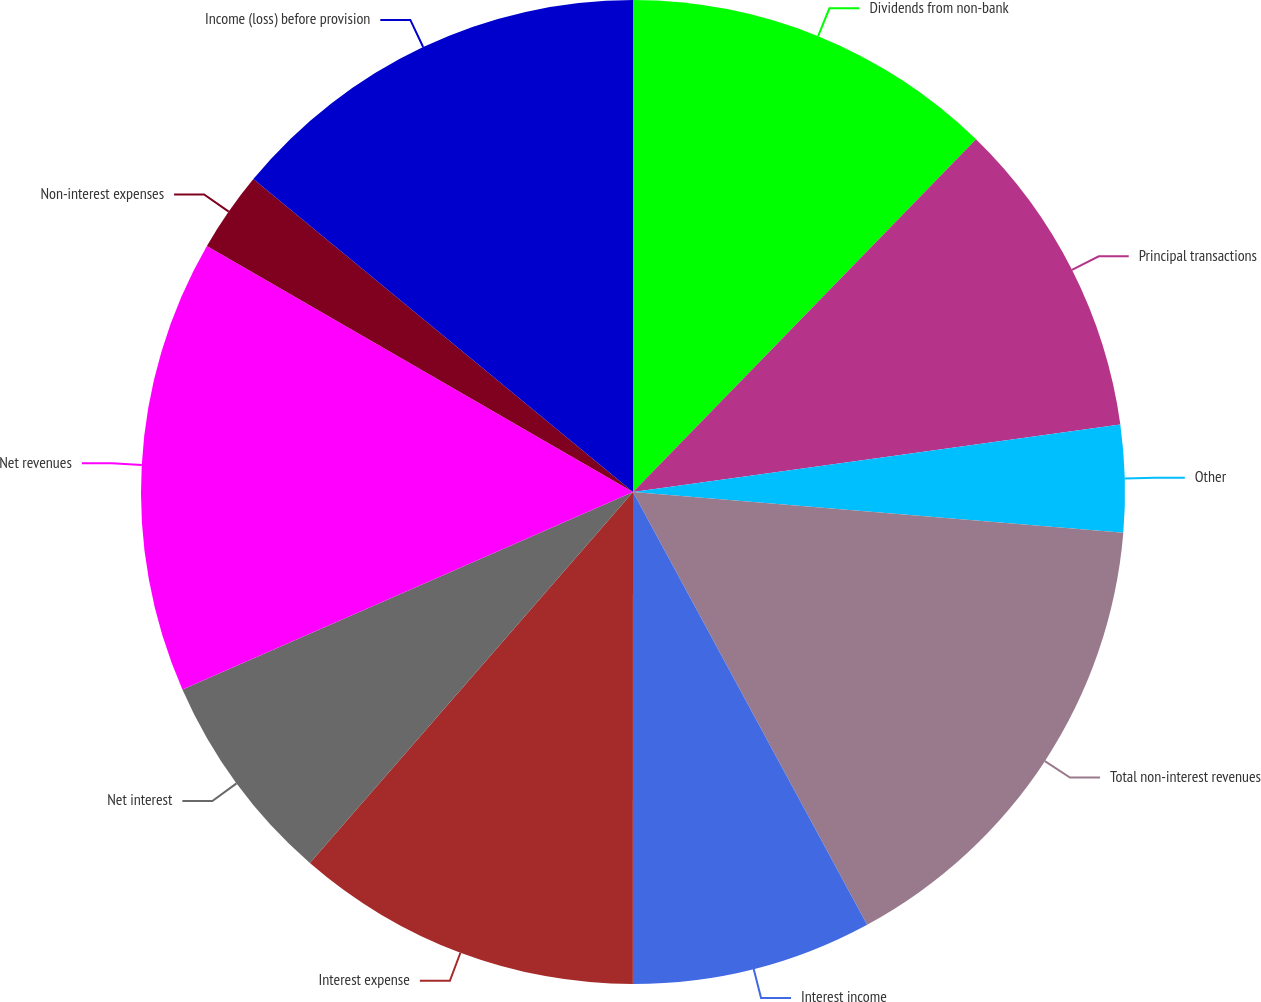Convert chart to OTSL. <chart><loc_0><loc_0><loc_500><loc_500><pie_chart><fcel>Dividends from non-bank<fcel>Principal transactions<fcel>Other<fcel>Total non-interest revenues<fcel>Interest income<fcel>Interest expense<fcel>Net interest<fcel>Net revenues<fcel>Non-interest expenses<fcel>Income (loss) before provision<nl><fcel>12.28%<fcel>10.53%<fcel>3.51%<fcel>15.79%<fcel>7.9%<fcel>11.4%<fcel>7.02%<fcel>14.91%<fcel>2.64%<fcel>14.03%<nl></chart> 